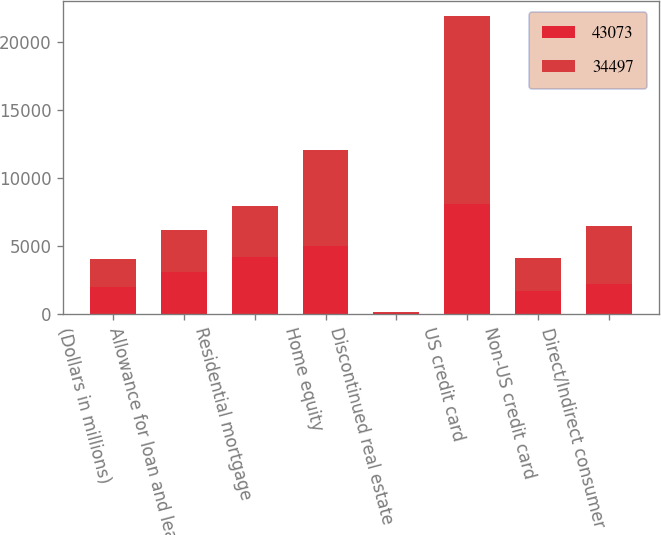Convert chart. <chart><loc_0><loc_0><loc_500><loc_500><stacked_bar_chart><ecel><fcel>(Dollars in millions)<fcel>Allowance for loan and lease<fcel>Residential mortgage<fcel>Home equity<fcel>Discontinued real estate<fcel>US credit card<fcel>Non-US credit card<fcel>Direct/Indirect consumer<nl><fcel>43073<fcel>2011<fcel>3101.5<fcel>4195<fcel>4990<fcel>106<fcel>8114<fcel>1691<fcel>2190<nl><fcel>34497<fcel>2010<fcel>3101.5<fcel>3779<fcel>7059<fcel>77<fcel>13818<fcel>2424<fcel>4303<nl></chart> 